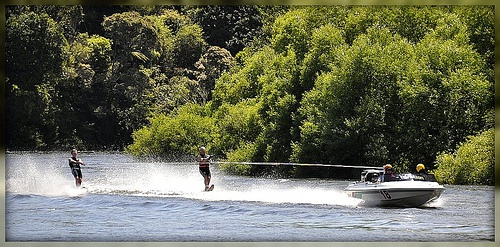Describe the objects in this image and their specific colors. I can see boat in black, white, gray, and darkgray tones, people in black, gray, maroon, and white tones, people in black, gray, darkgray, and white tones, people in black, gray, darkgray, and maroon tones, and people in black, gray, and olive tones in this image. 